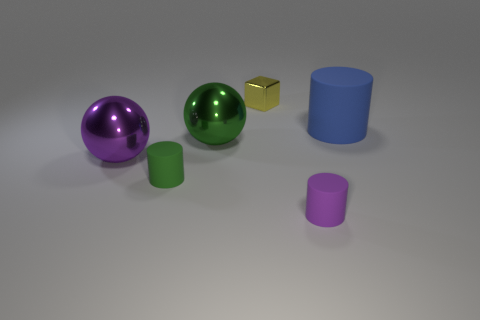Is the lighting coming from a specific direction in this scene? Yes, the lighting in the scene seems to be coming from above and to the right, as indicated by the shadows being cast towards the lower left side of the objects. 